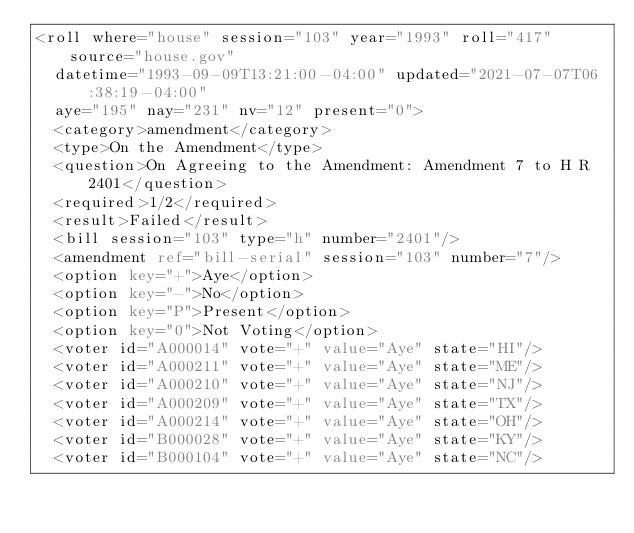Convert code to text. <code><loc_0><loc_0><loc_500><loc_500><_XML_><roll where="house" session="103" year="1993" roll="417" source="house.gov"
  datetime="1993-09-09T13:21:00-04:00" updated="2021-07-07T06:38:19-04:00"
  aye="195" nay="231" nv="12" present="0">
  <category>amendment</category>
  <type>On the Amendment</type>
  <question>On Agreeing to the Amendment: Amendment 7 to H R 2401</question>
  <required>1/2</required>
  <result>Failed</result>
  <bill session="103" type="h" number="2401"/>
  <amendment ref="bill-serial" session="103" number="7"/>
  <option key="+">Aye</option>
  <option key="-">No</option>
  <option key="P">Present</option>
  <option key="0">Not Voting</option>
  <voter id="A000014" vote="+" value="Aye" state="HI"/>
  <voter id="A000211" vote="+" value="Aye" state="ME"/>
  <voter id="A000210" vote="+" value="Aye" state="NJ"/>
  <voter id="A000209" vote="+" value="Aye" state="TX"/>
  <voter id="A000214" vote="+" value="Aye" state="OH"/>
  <voter id="B000028" vote="+" value="Aye" state="KY"/>
  <voter id="B000104" vote="+" value="Aye" state="NC"/></code> 